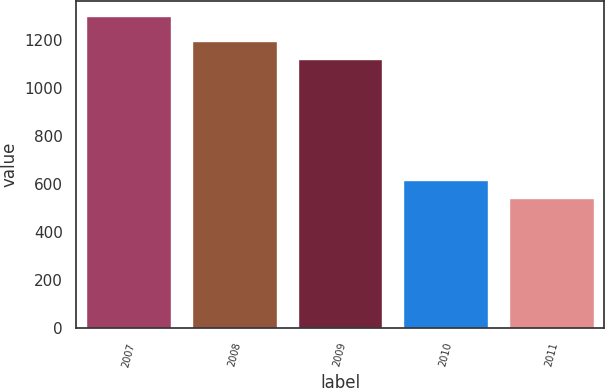<chart> <loc_0><loc_0><loc_500><loc_500><bar_chart><fcel>2007<fcel>2008<fcel>2009<fcel>2010<fcel>2011<nl><fcel>1297<fcel>1196.6<fcel>1121<fcel>616.6<fcel>541<nl></chart> 